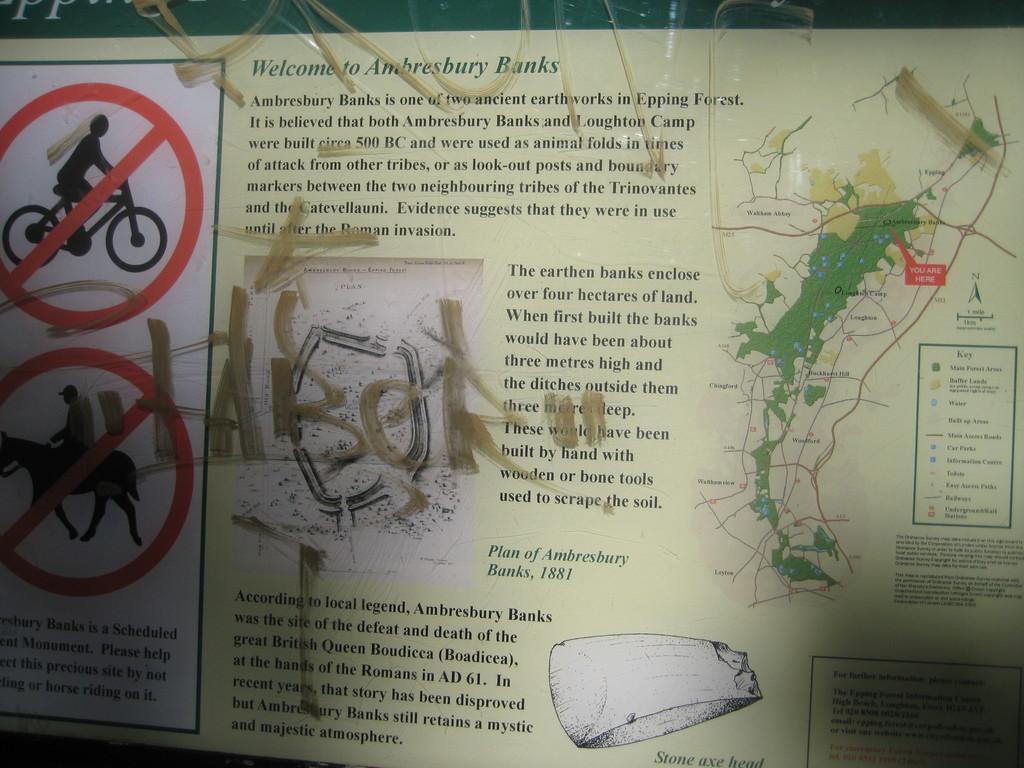Describe this image in one or two sentences. In this image we can see a poster with signs. Also something is written on that. And there is a map on that. 